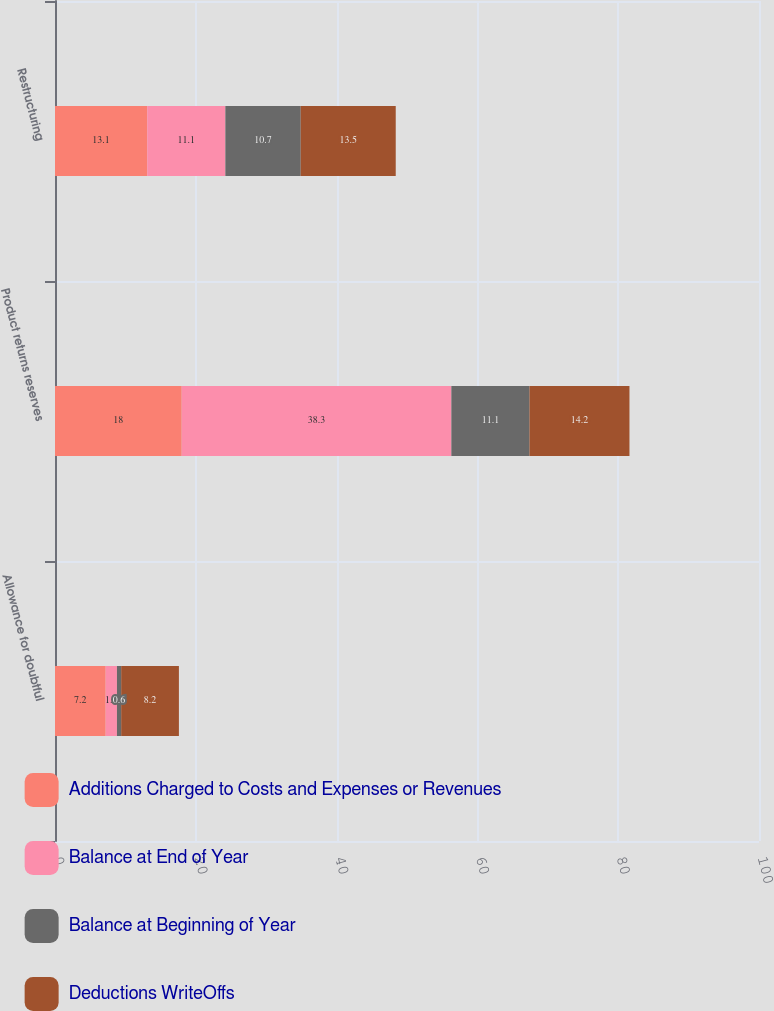<chart> <loc_0><loc_0><loc_500><loc_500><stacked_bar_chart><ecel><fcel>Allowance for doubtful<fcel>Product returns reserves<fcel>Restructuring<nl><fcel>Additions Charged to Costs and Expenses or Revenues<fcel>7.2<fcel>18<fcel>13.1<nl><fcel>Balance at End of Year<fcel>1.6<fcel>38.3<fcel>11.1<nl><fcel>Balance at Beginning of Year<fcel>0.6<fcel>11.1<fcel>10.7<nl><fcel>Deductions WriteOffs<fcel>8.2<fcel>14.2<fcel>13.5<nl></chart> 